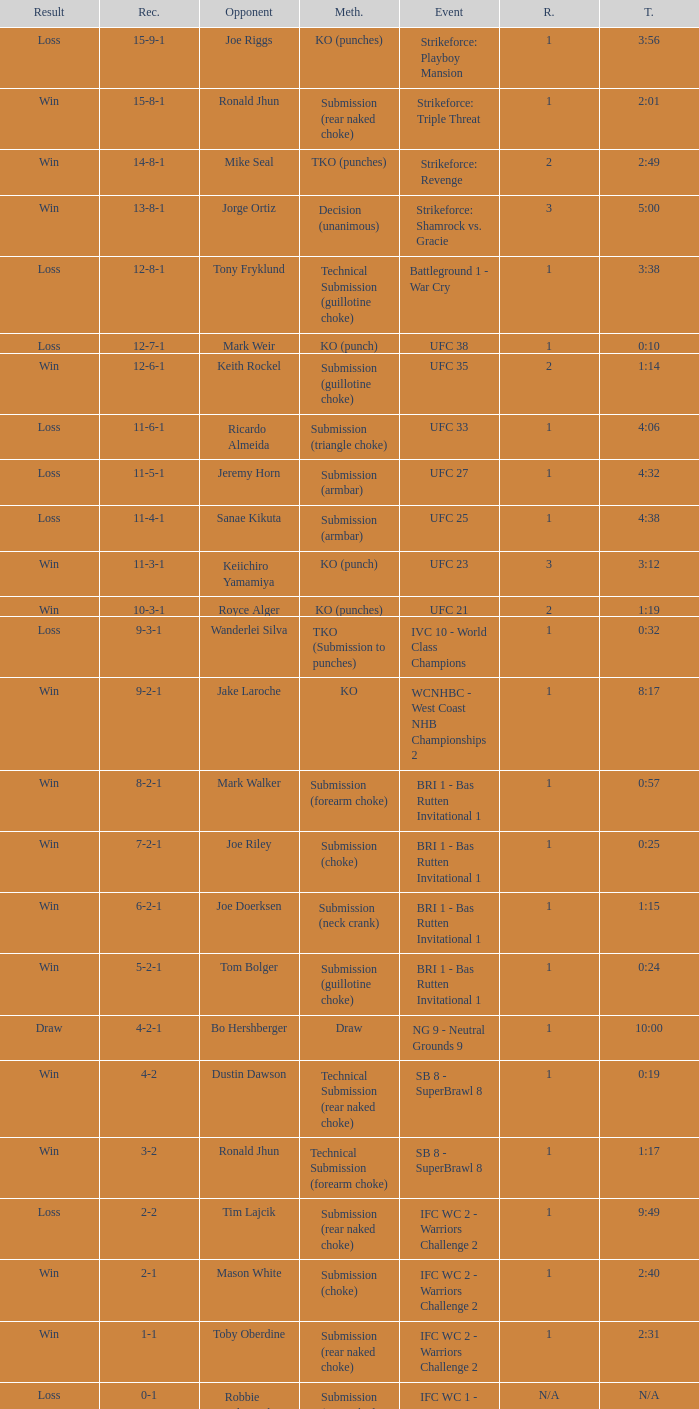What was the result when a knockout was used as the method of resolution? 9-2-1. Write the full table. {'header': ['Result', 'Rec.', 'Opponent', 'Meth.', 'Event', 'R.', 'T.'], 'rows': [['Loss', '15-9-1', 'Joe Riggs', 'KO (punches)', 'Strikeforce: Playboy Mansion', '1', '3:56'], ['Win', '15-8-1', 'Ronald Jhun', 'Submission (rear naked choke)', 'Strikeforce: Triple Threat', '1', '2:01'], ['Win', '14-8-1', 'Mike Seal', 'TKO (punches)', 'Strikeforce: Revenge', '2', '2:49'], ['Win', '13-8-1', 'Jorge Ortiz', 'Decision (unanimous)', 'Strikeforce: Shamrock vs. Gracie', '3', '5:00'], ['Loss', '12-8-1', 'Tony Fryklund', 'Technical Submission (guillotine choke)', 'Battleground 1 - War Cry', '1', '3:38'], ['Loss', '12-7-1', 'Mark Weir', 'KO (punch)', 'UFC 38', '1', '0:10'], ['Win', '12-6-1', 'Keith Rockel', 'Submission (guillotine choke)', 'UFC 35', '2', '1:14'], ['Loss', '11-6-1', 'Ricardo Almeida', 'Submission (triangle choke)', 'UFC 33', '1', '4:06'], ['Loss', '11-5-1', 'Jeremy Horn', 'Submission (armbar)', 'UFC 27', '1', '4:32'], ['Loss', '11-4-1', 'Sanae Kikuta', 'Submission (armbar)', 'UFC 25', '1', '4:38'], ['Win', '11-3-1', 'Keiichiro Yamamiya', 'KO (punch)', 'UFC 23', '3', '3:12'], ['Win', '10-3-1', 'Royce Alger', 'KO (punches)', 'UFC 21', '2', '1:19'], ['Loss', '9-3-1', 'Wanderlei Silva', 'TKO (Submission to punches)', 'IVC 10 - World Class Champions', '1', '0:32'], ['Win', '9-2-1', 'Jake Laroche', 'KO', 'WCNHBC - West Coast NHB Championships 2', '1', '8:17'], ['Win', '8-2-1', 'Mark Walker', 'Submission (forearm choke)', 'BRI 1 - Bas Rutten Invitational 1', '1', '0:57'], ['Win', '7-2-1', 'Joe Riley', 'Submission (choke)', 'BRI 1 - Bas Rutten Invitational 1', '1', '0:25'], ['Win', '6-2-1', 'Joe Doerksen', 'Submission (neck crank)', 'BRI 1 - Bas Rutten Invitational 1', '1', '1:15'], ['Win', '5-2-1', 'Tom Bolger', 'Submission (guillotine choke)', 'BRI 1 - Bas Rutten Invitational 1', '1', '0:24'], ['Draw', '4-2-1', 'Bo Hershberger', 'Draw', 'NG 9 - Neutral Grounds 9', '1', '10:00'], ['Win', '4-2', 'Dustin Dawson', 'Technical Submission (rear naked choke)', 'SB 8 - SuperBrawl 8', '1', '0:19'], ['Win', '3-2', 'Ronald Jhun', 'Technical Submission (forearm choke)', 'SB 8 - SuperBrawl 8', '1', '1:17'], ['Loss', '2-2', 'Tim Lajcik', 'Submission (rear naked choke)', 'IFC WC 2 - Warriors Challenge 2', '1', '9:49'], ['Win', '2-1', 'Mason White', 'Submission (choke)', 'IFC WC 2 - Warriors Challenge 2', '1', '2:40'], ['Win', '1-1', 'Toby Oberdine', 'Submission (rear naked choke)', 'IFC WC 2 - Warriors Challenge 2', '1', '2:31'], ['Loss', '0-1', 'Robbie Kilpatrick', 'Submission (rear naked choke)', 'IFC WC 1 - Warriors Challenge 1', 'N/A', 'N/A']]} 